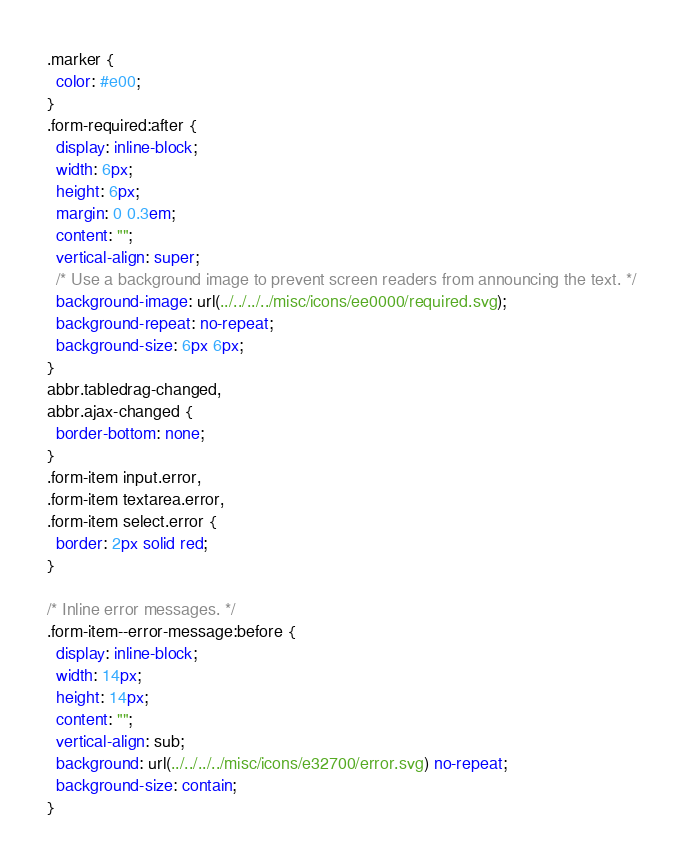<code> <loc_0><loc_0><loc_500><loc_500><_CSS_>.marker {
  color: #e00;
}
.form-required:after {
  display: inline-block;
  width: 6px;
  height: 6px;
  margin: 0 0.3em;
  content: "";
  vertical-align: super;
  /* Use a background image to prevent screen readers from announcing the text. */
  background-image: url(../../../../misc/icons/ee0000/required.svg);
  background-repeat: no-repeat;
  background-size: 6px 6px;
}
abbr.tabledrag-changed,
abbr.ajax-changed {
  border-bottom: none;
}
.form-item input.error,
.form-item textarea.error,
.form-item select.error {
  border: 2px solid red;
}

/* Inline error messages. */
.form-item--error-message:before {
  display: inline-block;
  width: 14px;
  height: 14px;
  content: "";
  vertical-align: sub;
  background: url(../../../../misc/icons/e32700/error.svg) no-repeat;
  background-size: contain;
}
</code> 